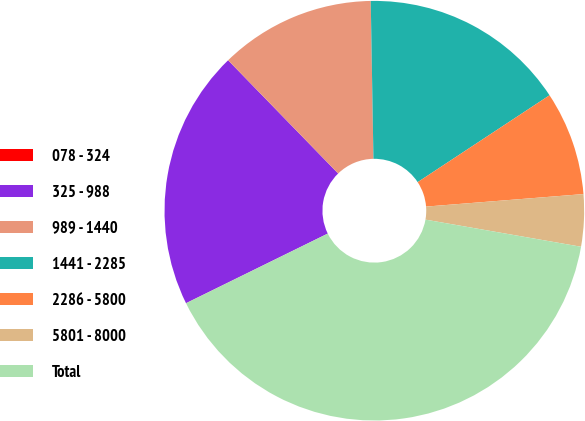<chart> <loc_0><loc_0><loc_500><loc_500><pie_chart><fcel>078 - 324<fcel>325 - 988<fcel>989 - 1440<fcel>1441 - 2285<fcel>2286 - 5800<fcel>5801 - 8000<fcel>Total<nl><fcel>0.01%<fcel>19.99%<fcel>12.0%<fcel>16.0%<fcel>8.01%<fcel>4.01%<fcel>39.98%<nl></chart> 